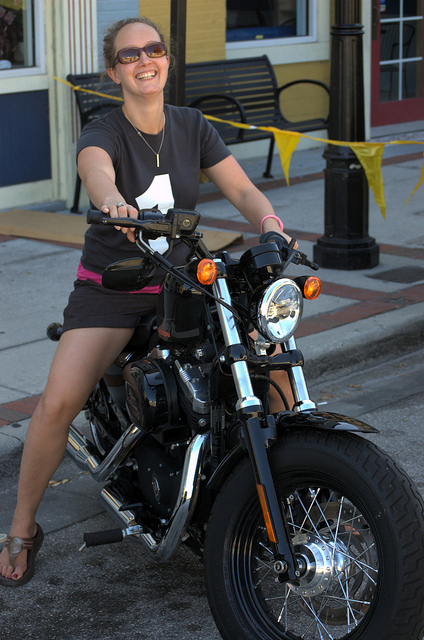<image>What color is the woman's belt? It's ambiguous what the color of the woman's belt is. It could be pink or black, or she may not have a belt. What color is the woman's belt? I am not sure what color is the woman's belt. It can be seen pink or black. 